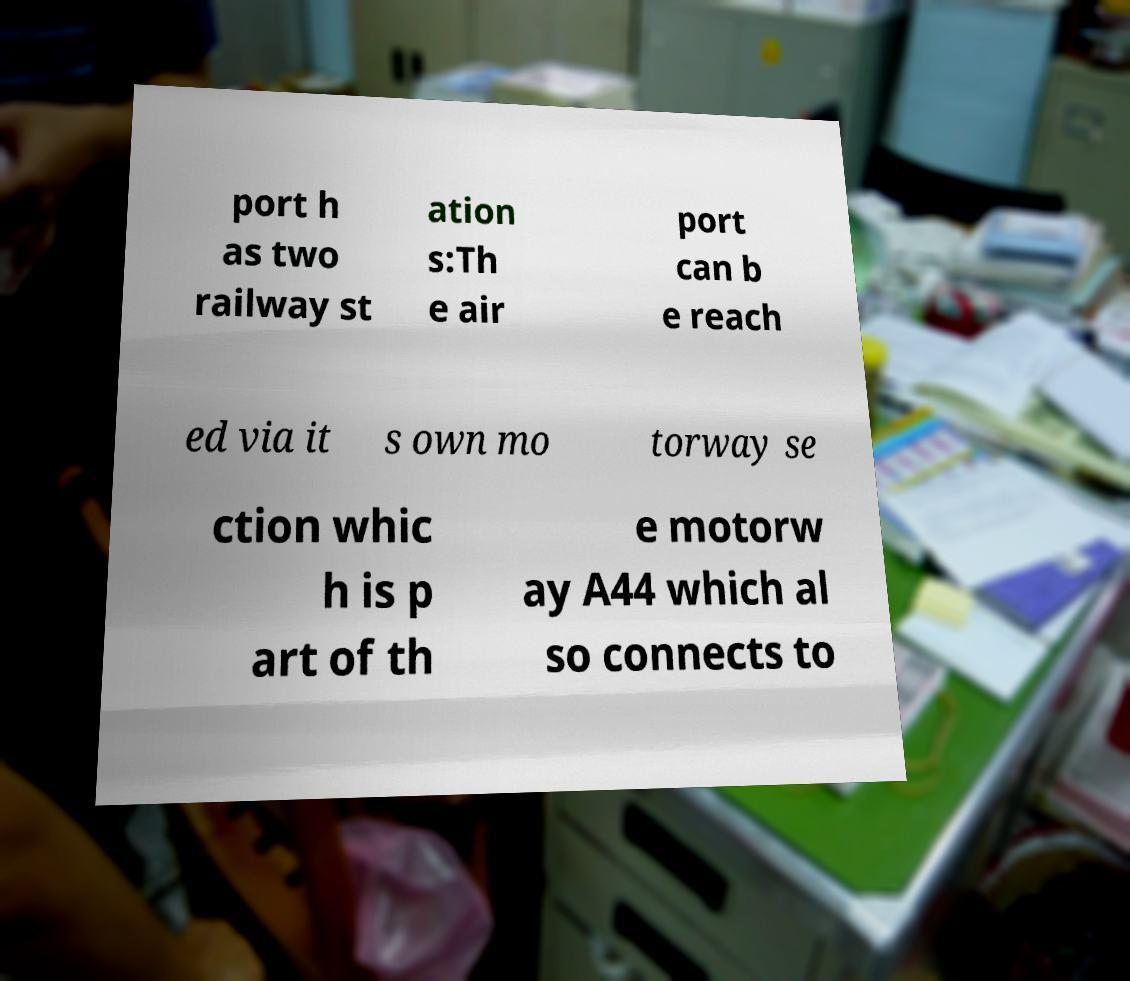Could you extract and type out the text from this image? port h as two railway st ation s:Th e air port can b e reach ed via it s own mo torway se ction whic h is p art of th e motorw ay A44 which al so connects to 